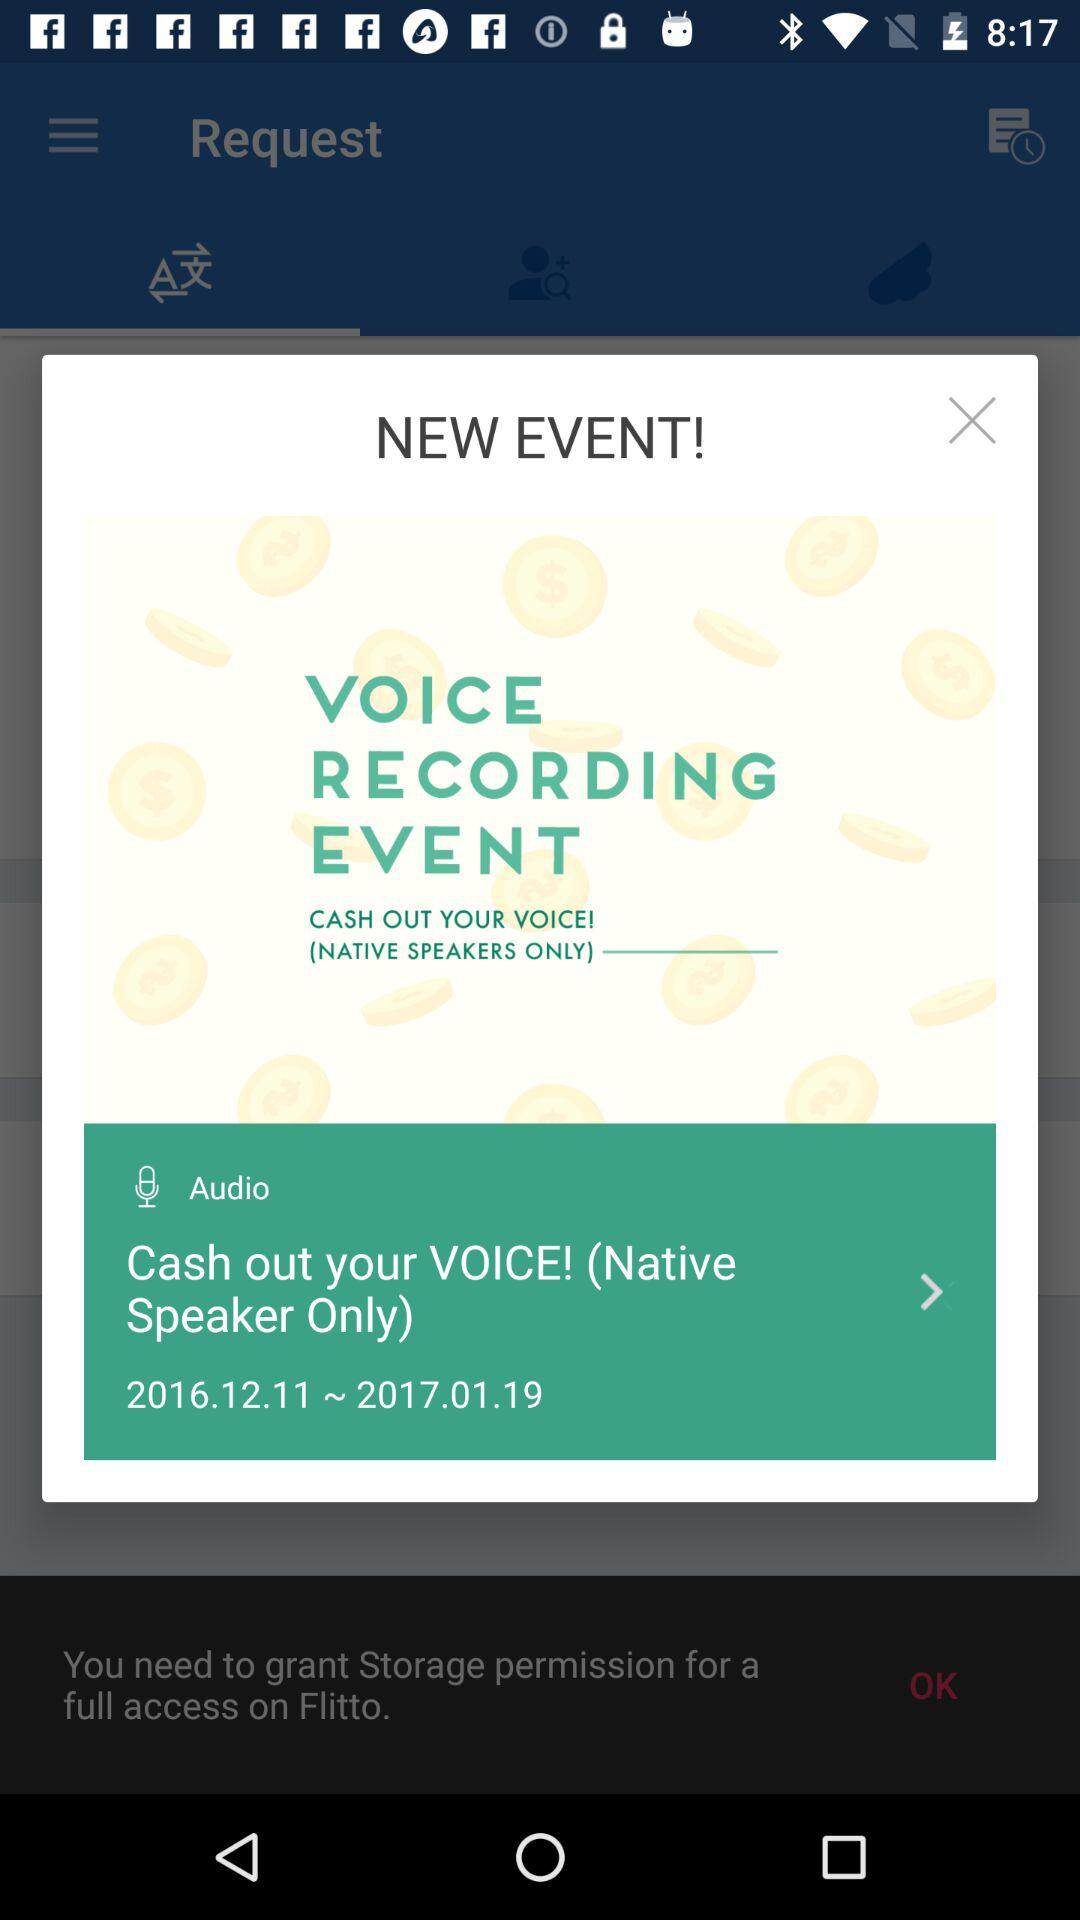What is the name of the event? The name of the event is "VOICE RECORDING EVENT". 